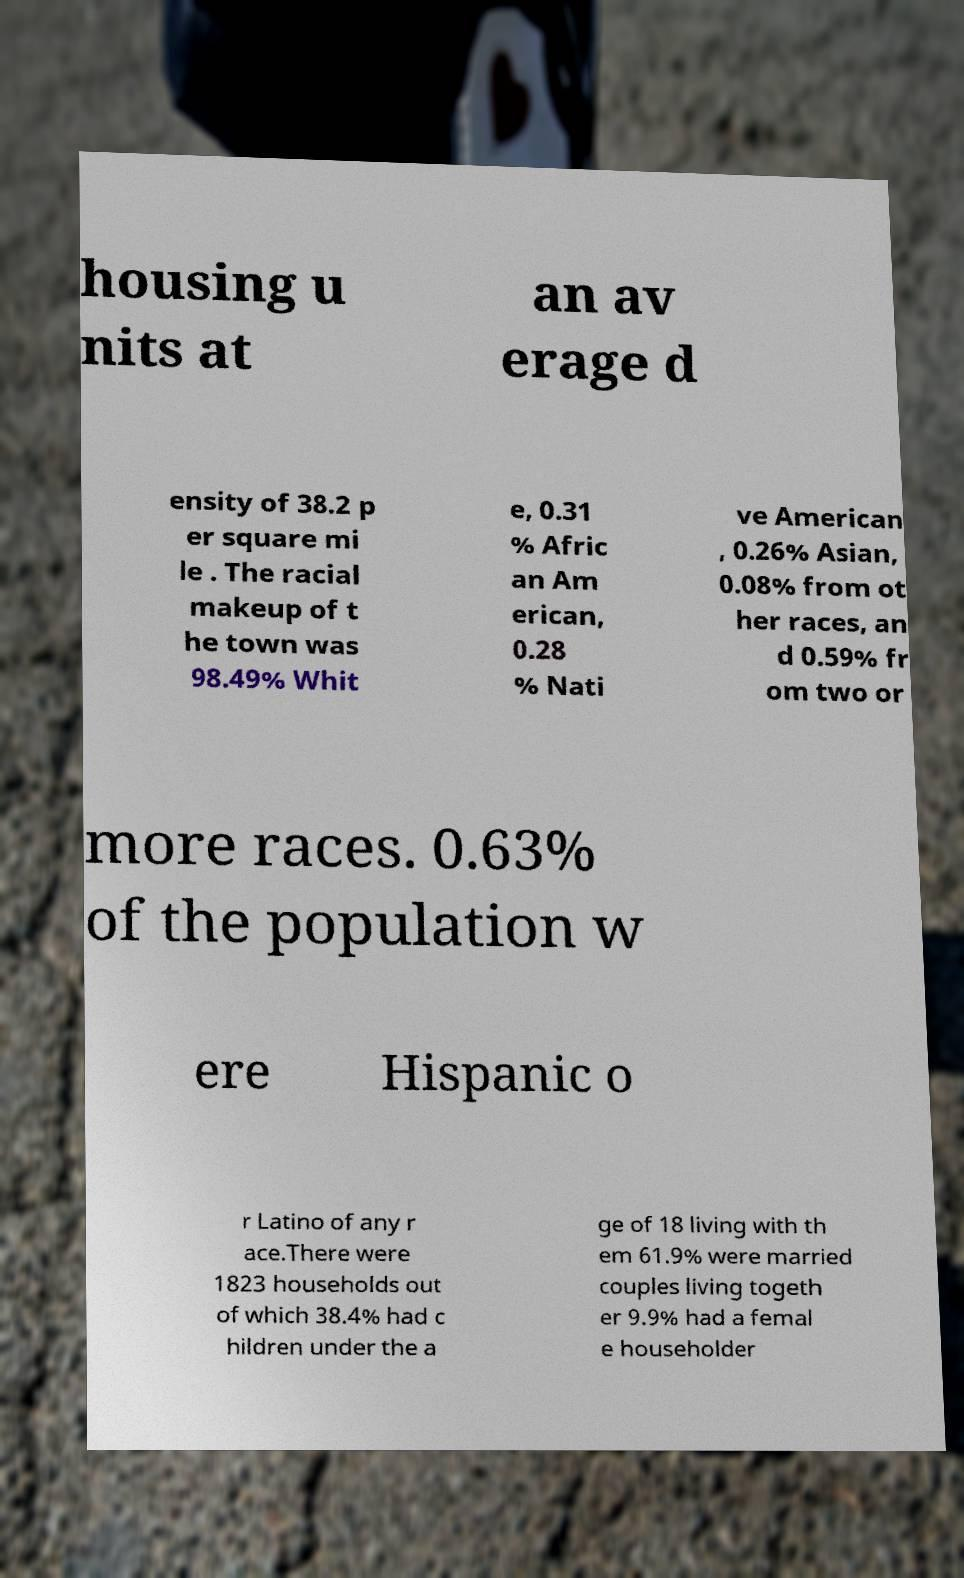Please read and relay the text visible in this image. What does it say? housing u nits at an av erage d ensity of 38.2 p er square mi le . The racial makeup of t he town was 98.49% Whit e, 0.31 % Afric an Am erican, 0.28 % Nati ve American , 0.26% Asian, 0.08% from ot her races, an d 0.59% fr om two or more races. 0.63% of the population w ere Hispanic o r Latino of any r ace.There were 1823 households out of which 38.4% had c hildren under the a ge of 18 living with th em 61.9% were married couples living togeth er 9.9% had a femal e householder 